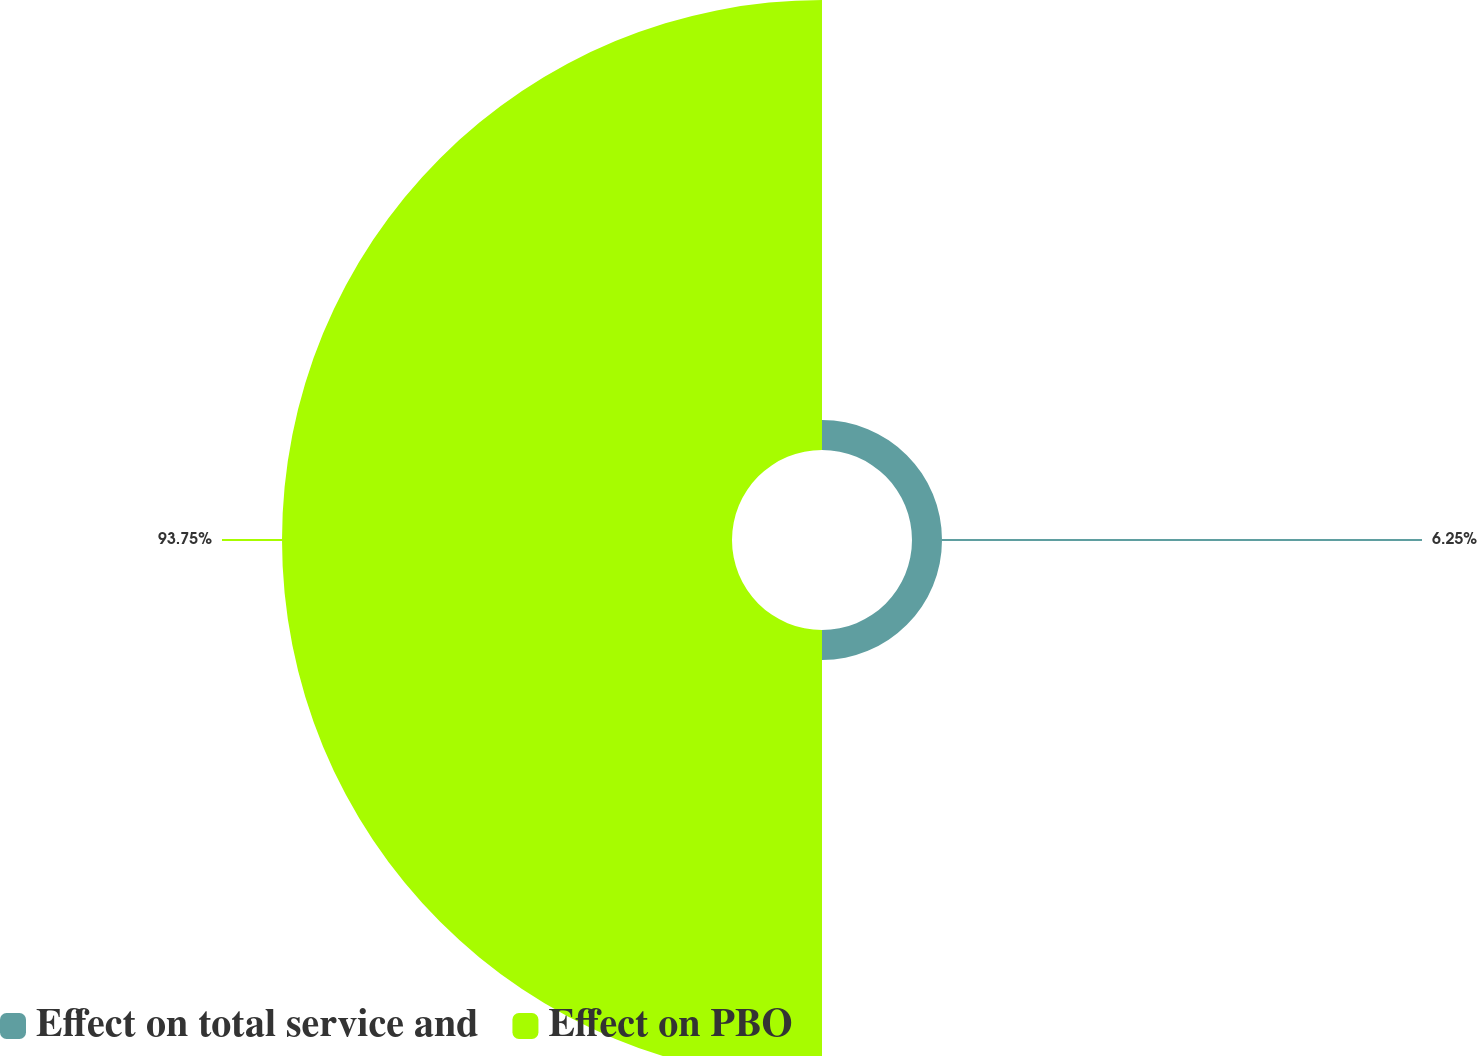<chart> <loc_0><loc_0><loc_500><loc_500><pie_chart><fcel>Effect on total service and<fcel>Effect on PBO<nl><fcel>6.25%<fcel>93.75%<nl></chart> 